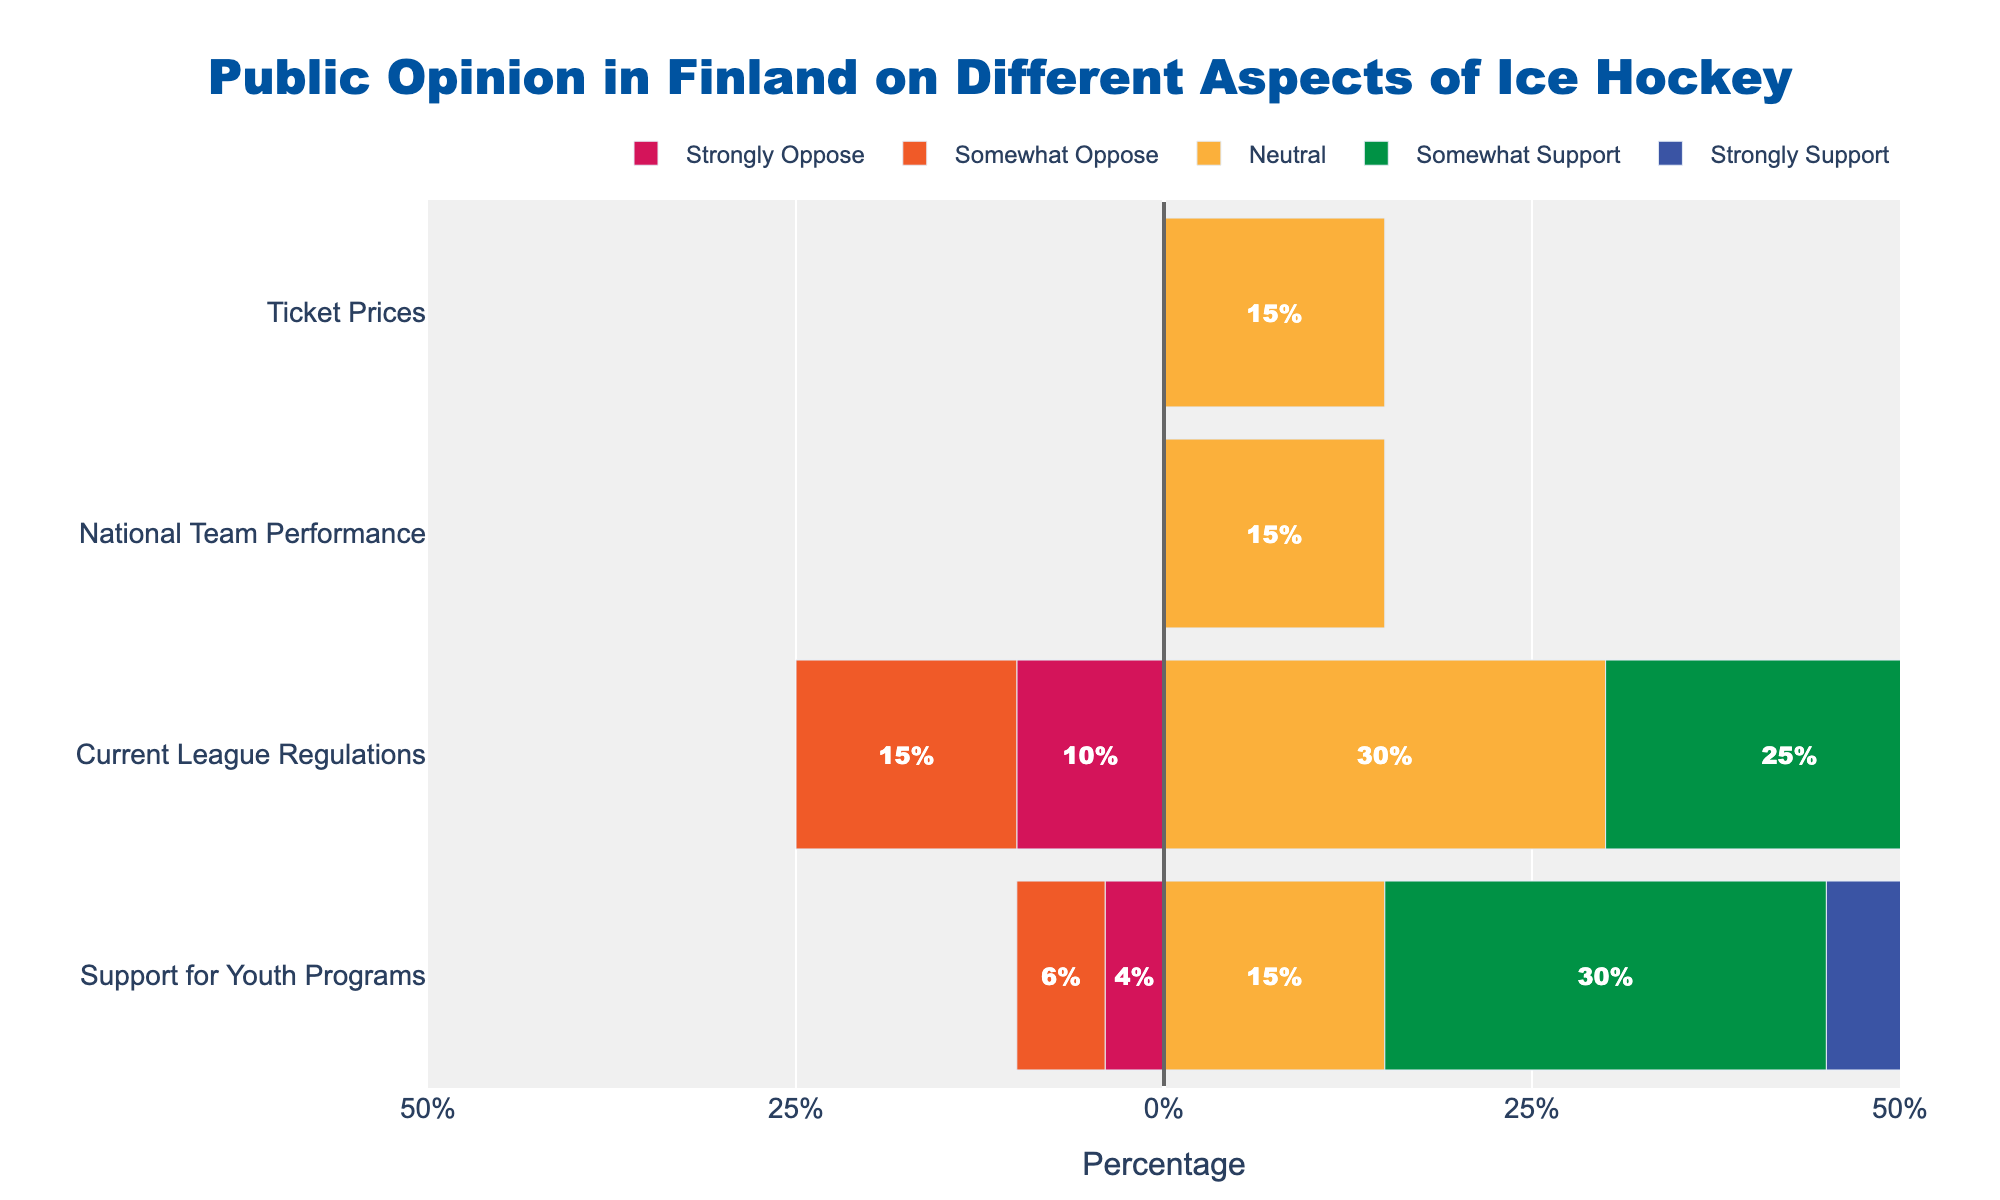What is the percentage of people who strongly support and somewhat support youth programs combined? The percentage of people who strongly support youth programs is 45% and those who somewhat support is 30%. Adding these together: 45% + 30% = 75%
Answer: 75% Which aspect has the highest percentage of 'Very Satisfied' responses? The aspect with the highest percentage of 'Very Satisfied' responses is 'National Team Performance' with 35%.
Answer: National Team Performance How does the support for current league regulations compare between 'Somewhat Support' and 'Somewhat Oppose'? The percentage of people who somewhat support current league regulations is 25%, while those who somewhat oppose is 15%. Therefore, somewhat support is higher by 10%.
Answer: Somewhat Support is higher by 10% What is the difference in satisfaction between 'Very Dissatisfied' with ticket prices and 'Somewhat Dissatisfied' with ticket prices? The percentage of people very dissatisfied with ticket prices is 25%, and those somewhat dissatisfied is 30%. The difference is 30% - 25% = 5%.
Answer: 5% What percentage of people have a neutral opinion on current league regulations? The percentage of people who are neutral about current league regulations is 30%.
Answer: 30% Which aspect has the lowest percentage of 'Strongly Oppose' responses? The aspect with the lowest percentage of 'Strongly Oppose' responses is 'Support for Youth Programs' with 4%.
Answer: Support for Youth Programs Compare the 'Strongly Oppose' opinions between 'Support for Youth Programs' and 'Current League Regulations'. The percentage of people who strongly oppose youth programs is 4%, while for current league regulations, it is 10%. Current league regulations have a higher percentage by 6%.
Answer: Current League Regulations have higher by 6% What is the total percentage of people who have a positive opinion ('Somewhat Support' and 'Strongly Support') on current league regulations? The percentage of people who somewhat support current league regulations is 25%, and those who strongly support is 20%. Adding these together gives: 25% + 20% = 45%.
Answer: 45% How does the neutrality on national team performance compare to the neutrality on support for youth programs? The percentage of people neutral on national team performance is 15%, same as those who are neutral on support for youth programs, also at 15%.
Answer: Equal at 15% Which aspect has the highest percentage of negative opinions ('Somewhat Oppose' and 'Strongly Oppose')? The aspect with the highest combined percentage of negative opinions is 'Ticket Prices' with 'Somewhat Dissatisfied' at 30% and 'Very Dissatisfied' at 25%, totaling 55%.
Answer: Ticket Prices 